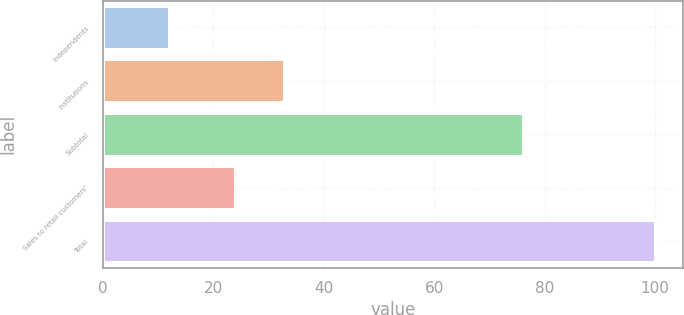<chart> <loc_0><loc_0><loc_500><loc_500><bar_chart><fcel>Independents<fcel>Institutions<fcel>Subtotal<fcel>Sales to retail customers'<fcel>Total<nl><fcel>12<fcel>32.8<fcel>76<fcel>24<fcel>100<nl></chart> 